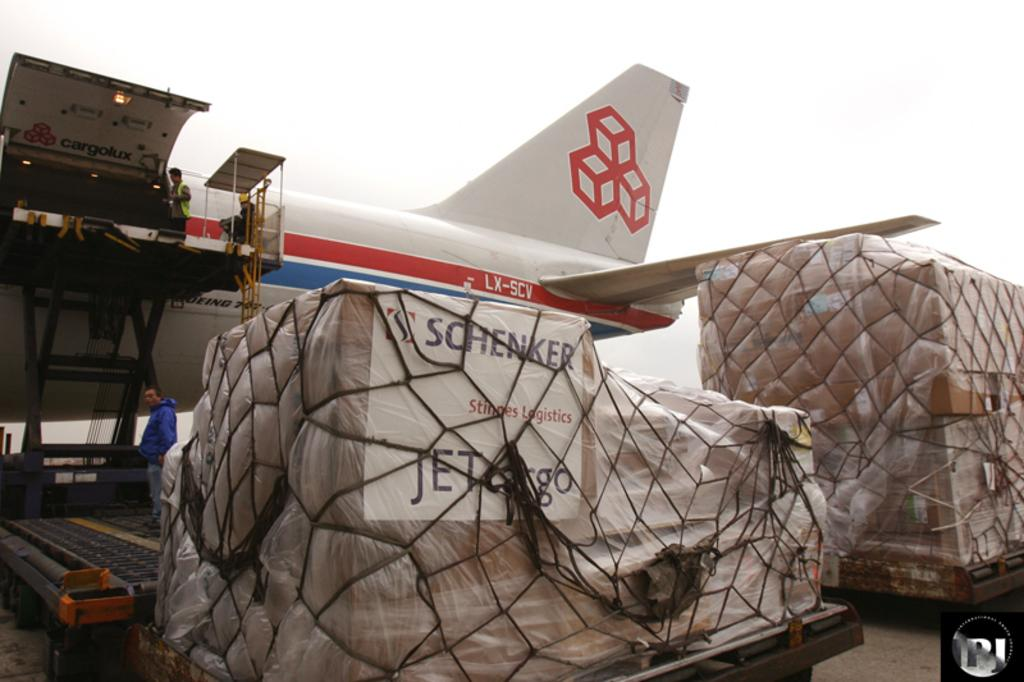<image>
Share a concise interpretation of the image provided. LX SCV is printed on a jet that is parked near cargo. 